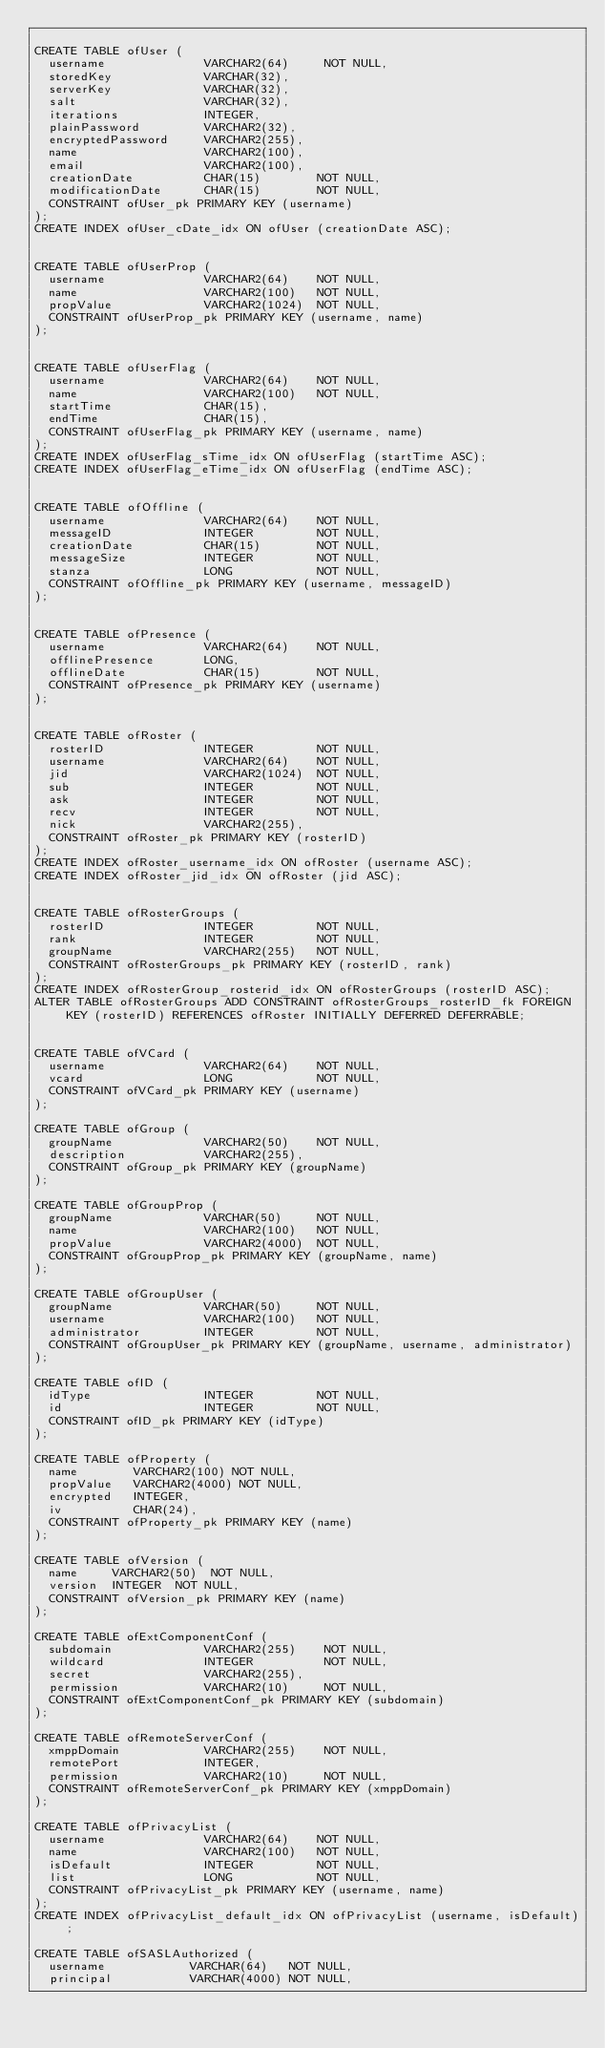Convert code to text. <code><loc_0><loc_0><loc_500><loc_500><_SQL_>
CREATE TABLE ofUser (
  username              VARCHAR2(64)     NOT NULL,
  storedKey             VARCHAR(32),
  serverKey             VARCHAR(32),
  salt                  VARCHAR(32),
  iterations            INTEGER,
  plainPassword         VARCHAR2(32),
  encryptedPassword     VARCHAR2(255),
  name                  VARCHAR2(100),
  email                 VARCHAR2(100),
  creationDate          CHAR(15)        NOT NULL,
  modificationDate      CHAR(15)        NOT NULL,
  CONSTRAINT ofUser_pk PRIMARY KEY (username)
);
CREATE INDEX ofUser_cDate_idx ON ofUser (creationDate ASC);


CREATE TABLE ofUserProp (
  username              VARCHAR2(64)    NOT NULL,
  name                  VARCHAR2(100)   NOT NULL,
  propValue             VARCHAR2(1024)  NOT NULL,
  CONSTRAINT ofUserProp_pk PRIMARY KEY (username, name)
);


CREATE TABLE ofUserFlag (
  username              VARCHAR2(64)    NOT NULL,
  name                  VARCHAR2(100)   NOT NULL,
  startTime             CHAR(15),
  endTime               CHAR(15),
  CONSTRAINT ofUserFlag_pk PRIMARY KEY (username, name)
);
CREATE INDEX ofUserFlag_sTime_idx ON ofUserFlag (startTime ASC);
CREATE INDEX ofUserFlag_eTime_idx ON ofUserFlag (endTime ASC);


CREATE TABLE ofOffline (
  username              VARCHAR2(64)    NOT NULL,
  messageID             INTEGER         NOT NULL,
  creationDate          CHAR(15)        NOT NULL,
  messageSize           INTEGER         NOT NULL,
  stanza                LONG            NOT NULL,
  CONSTRAINT ofOffline_pk PRIMARY KEY (username, messageID)
);


CREATE TABLE ofPresence (
  username              VARCHAR2(64)    NOT NULL,
  offlinePresence       LONG,
  offlineDate           CHAR(15)        NOT NULL,
  CONSTRAINT ofPresence_pk PRIMARY KEY (username)
);


CREATE TABLE ofRoster (
  rosterID              INTEGER         NOT NULL,
  username              VARCHAR2(64)    NOT NULL,
  jid                   VARCHAR2(1024)  NOT NULL,
  sub                   INTEGER         NOT NULL,
  ask                   INTEGER         NOT NULL,
  recv                  INTEGER         NOT NULL,
  nick                  VARCHAR2(255),
  CONSTRAINT ofRoster_pk PRIMARY KEY (rosterID)
);
CREATE INDEX ofRoster_username_idx ON ofRoster (username ASC);
CREATE INDEX ofRoster_jid_idx ON ofRoster (jid ASC);


CREATE TABLE ofRosterGroups (
  rosterID              INTEGER         NOT NULL,
  rank                  INTEGER         NOT NULL,
  groupName             VARCHAR2(255)   NOT NULL,
  CONSTRAINT ofRosterGroups_pk PRIMARY KEY (rosterID, rank)
);
CREATE INDEX ofRosterGroup_rosterid_idx ON ofRosterGroups (rosterID ASC);
ALTER TABLE ofRosterGroups ADD CONSTRAINT ofRosterGroups_rosterID_fk FOREIGN KEY (rosterID) REFERENCES ofRoster INITIALLY DEFERRED DEFERRABLE;


CREATE TABLE ofVCard (
  username              VARCHAR2(64)    NOT NULL,
  vcard                 LONG            NOT NULL,
  CONSTRAINT ofVCard_pk PRIMARY KEY (username)
);

CREATE TABLE ofGroup (
  groupName             VARCHAR2(50)    NOT NULL,
  description           VARCHAR2(255),
  CONSTRAINT ofGroup_pk PRIMARY KEY (groupName)
);

CREATE TABLE ofGroupProp (
  groupName             VARCHAR(50)     NOT NULL,
  name                  VARCHAR2(100)   NOT NULL,
  propValue             VARCHAR2(4000)  NOT NULL,
  CONSTRAINT ofGroupProp_pk PRIMARY KEY (groupName, name)
);

CREATE TABLE ofGroupUser (
  groupName             VARCHAR(50)     NOT NULL,
  username              VARCHAR2(100)   NOT NULL,
  administrator         INTEGER         NOT NULL,
  CONSTRAINT ofGroupUser_pk PRIMARY KEY (groupName, username, administrator)
);

CREATE TABLE ofID (
  idType                INTEGER         NOT NULL,
  id                    INTEGER         NOT NULL,
  CONSTRAINT ofID_pk PRIMARY KEY (idType)
);

CREATE TABLE ofProperty (
  name        VARCHAR2(100) NOT NULL,
  propValue   VARCHAR2(4000) NOT NULL,
  encrypted   INTEGER,
  iv          CHAR(24),
  CONSTRAINT ofProperty_pk PRIMARY KEY (name)
);

CREATE TABLE ofVersion (
  name     VARCHAR2(50)  NOT NULL,
  version  INTEGER  NOT NULL,
  CONSTRAINT ofVersion_pk PRIMARY KEY (name)
);

CREATE TABLE ofExtComponentConf (
  subdomain             VARCHAR2(255)    NOT NULL,
  wildcard              INTEGER          NOT NULL,
  secret                VARCHAR2(255),
  permission            VARCHAR2(10)     NOT NULL,
  CONSTRAINT ofExtComponentConf_pk PRIMARY KEY (subdomain)
);

CREATE TABLE ofRemoteServerConf (
  xmppDomain            VARCHAR2(255)    NOT NULL,
  remotePort            INTEGER,
  permission            VARCHAR2(10)     NOT NULL,
  CONSTRAINT ofRemoteServerConf_pk PRIMARY KEY (xmppDomain)
);

CREATE TABLE ofPrivacyList (
  username              VARCHAR2(64)    NOT NULL,
  name                  VARCHAR2(100)   NOT NULL,
  isDefault             INTEGER         NOT NULL,
  list                  LONG            NOT NULL,
  CONSTRAINT ofPrivacyList_pk PRIMARY KEY (username, name)
);
CREATE INDEX ofPrivacyList_default_idx ON ofPrivacyList (username, isDefault);

CREATE TABLE ofSASLAuthorized (
  username            VARCHAR(64)   NOT NULL,
  principal           VARCHAR(4000) NOT NULL,</code> 